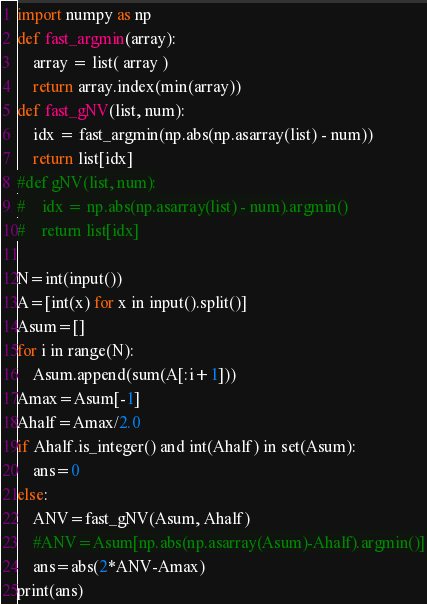Convert code to text. <code><loc_0><loc_0><loc_500><loc_500><_Python_>import numpy as np
def fast_argmin(array):
    array = list( array )
    return array.index(min(array))
def fast_gNV(list, num):
    idx = fast_argmin(np.abs(np.asarray(list) - num))
    return list[idx]
#def gNV(list, num):
#    idx = np.abs(np.asarray(list) - num).argmin()
#    return list[idx]

N=int(input())
A=[int(x) for x in input().split()]
Asum=[]
for i in range(N):
    Asum.append(sum(A[:i+1]))
Amax=Asum[-1]
Ahalf=Amax/2.0
if Ahalf.is_integer() and int(Ahalf) in set(Asum):
    ans=0
else:
    ANV=fast_gNV(Asum, Ahalf)
    #ANV=Asum[np.abs(np.asarray(Asum)-Ahalf).argmin()]
    ans=abs(2*ANV-Amax)
print(ans)    
</code> 